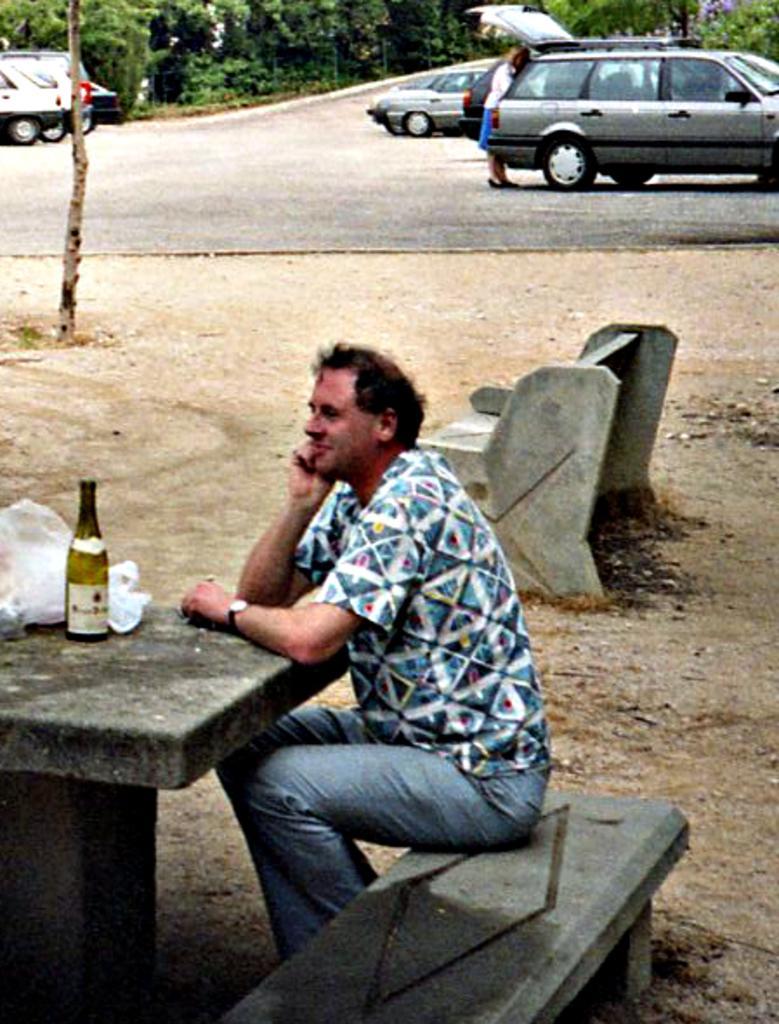Could you give a brief overview of what you see in this image? There is a man sitting on the table and a cover and a bottle is placed on the table. An empty chair is located in the right side of the image. In the background there are many cars placed on the both sides. A lady who has opened her trunk of the car. 